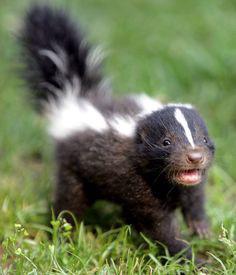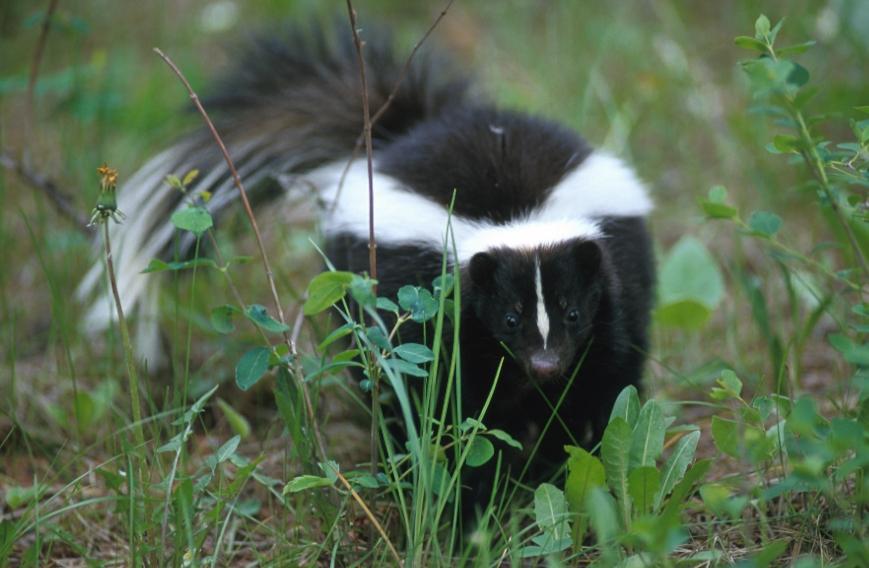The first image is the image on the left, the second image is the image on the right. Evaluate the accuracy of this statement regarding the images: "The right image includes at least two somewhat forward-angled side-by-side skunks with their tails up.". Is it true? Answer yes or no. No. The first image is the image on the left, the second image is the image on the right. Analyze the images presented: Is the assertion "There are more than two skunks in total." valid? Answer yes or no. No. 